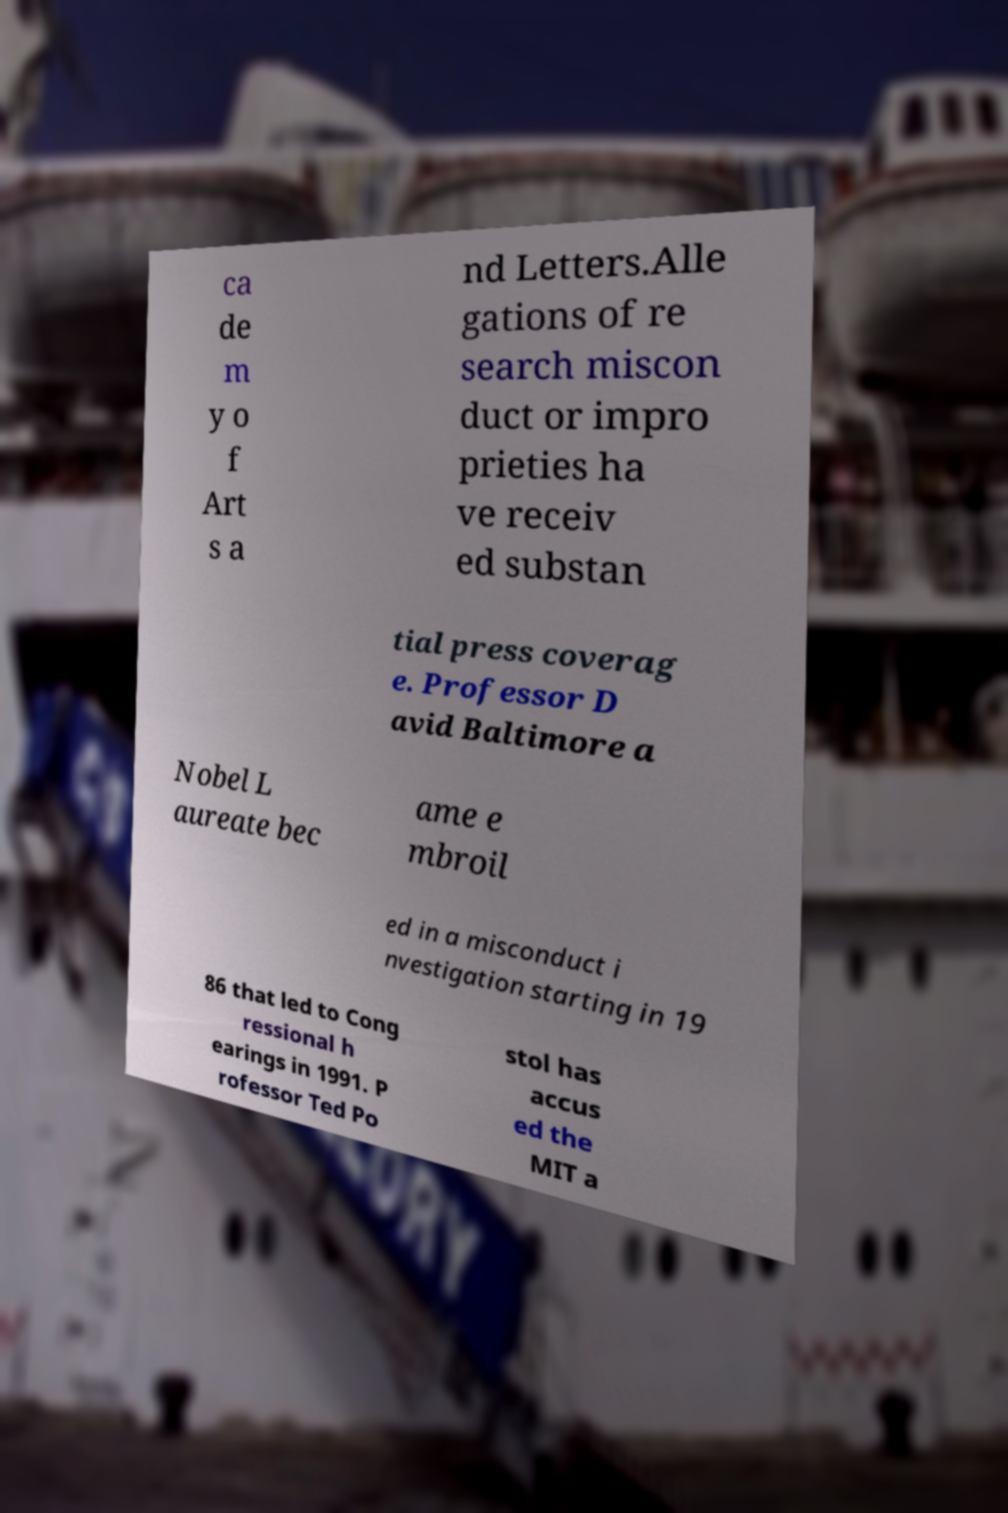Could you assist in decoding the text presented in this image and type it out clearly? ca de m y o f Art s a nd Letters.Alle gations of re search miscon duct or impro prieties ha ve receiv ed substan tial press coverag e. Professor D avid Baltimore a Nobel L aureate bec ame e mbroil ed in a misconduct i nvestigation starting in 19 86 that led to Cong ressional h earings in 1991. P rofessor Ted Po stol has accus ed the MIT a 